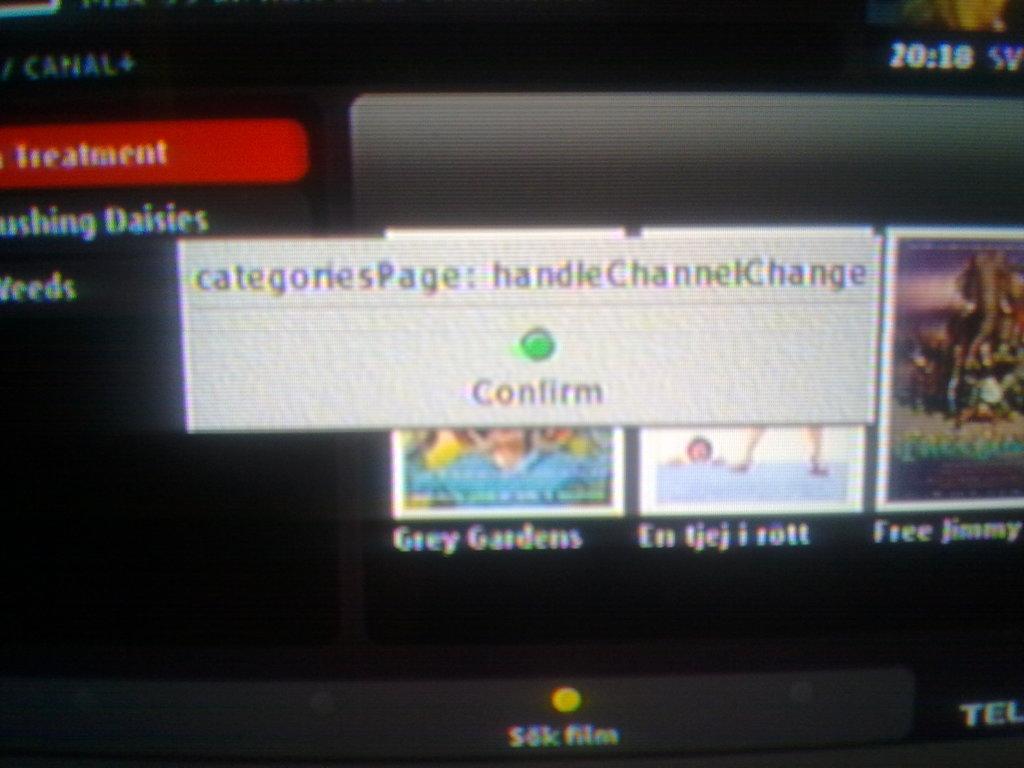What is the green bottom for?
Offer a very short reply. Confirm. What is the time?
Make the answer very short. 20:18. 